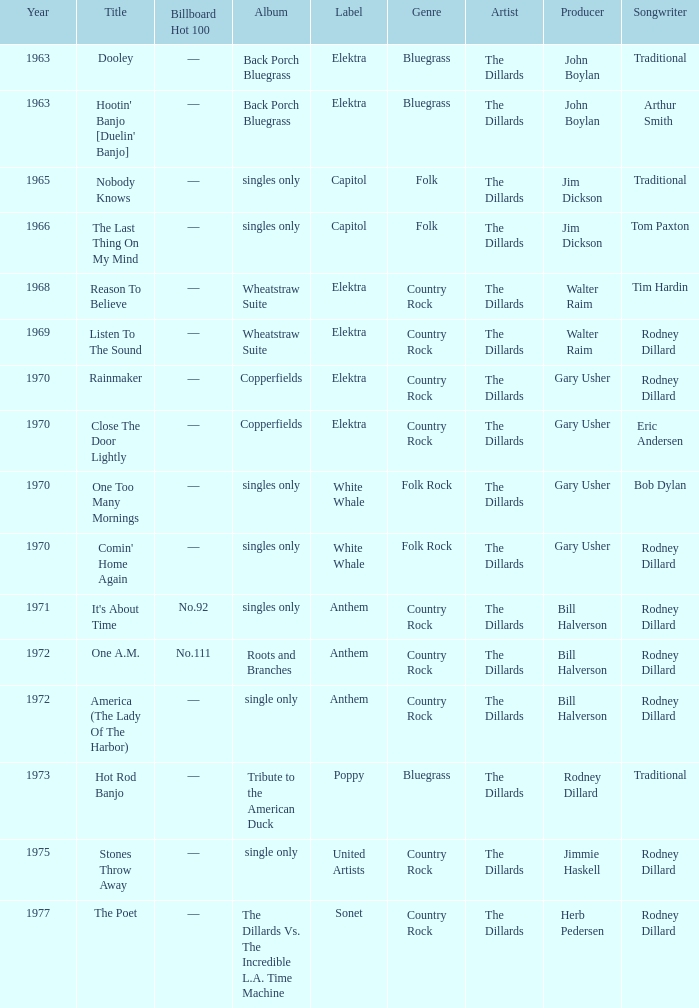What is the combined duration for roots and branches? 1972.0. 